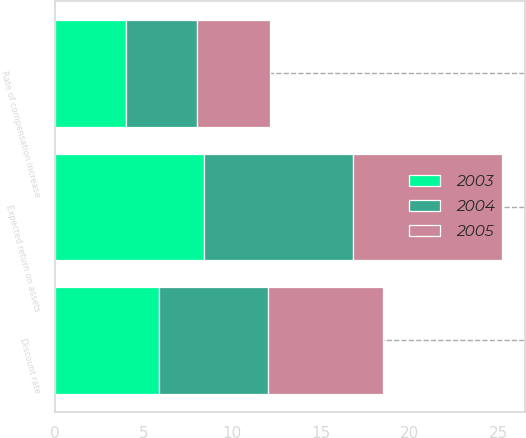<chart> <loc_0><loc_0><loc_500><loc_500><stacked_bar_chart><ecel><fcel>Discount rate<fcel>Expected return on assets<fcel>Rate of compensation increase<nl><fcel>2003<fcel>5.9<fcel>8.4<fcel>4<nl><fcel>2004<fcel>6.1<fcel>8.4<fcel>4<nl><fcel>2005<fcel>6.5<fcel>8.4<fcel>4.1<nl></chart> 